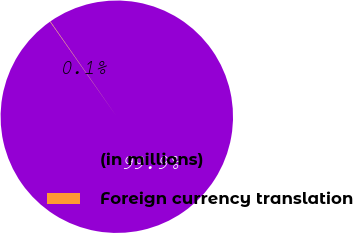<chart> <loc_0><loc_0><loc_500><loc_500><pie_chart><fcel>(in millions)<fcel>Foreign currency translation<nl><fcel>99.95%<fcel>0.05%<nl></chart> 